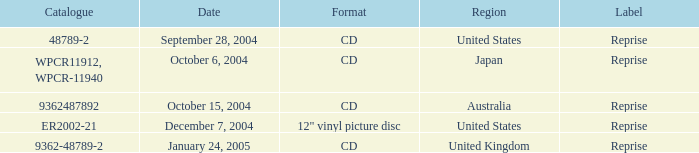Name the label for january 24, 2005 Reprise. 